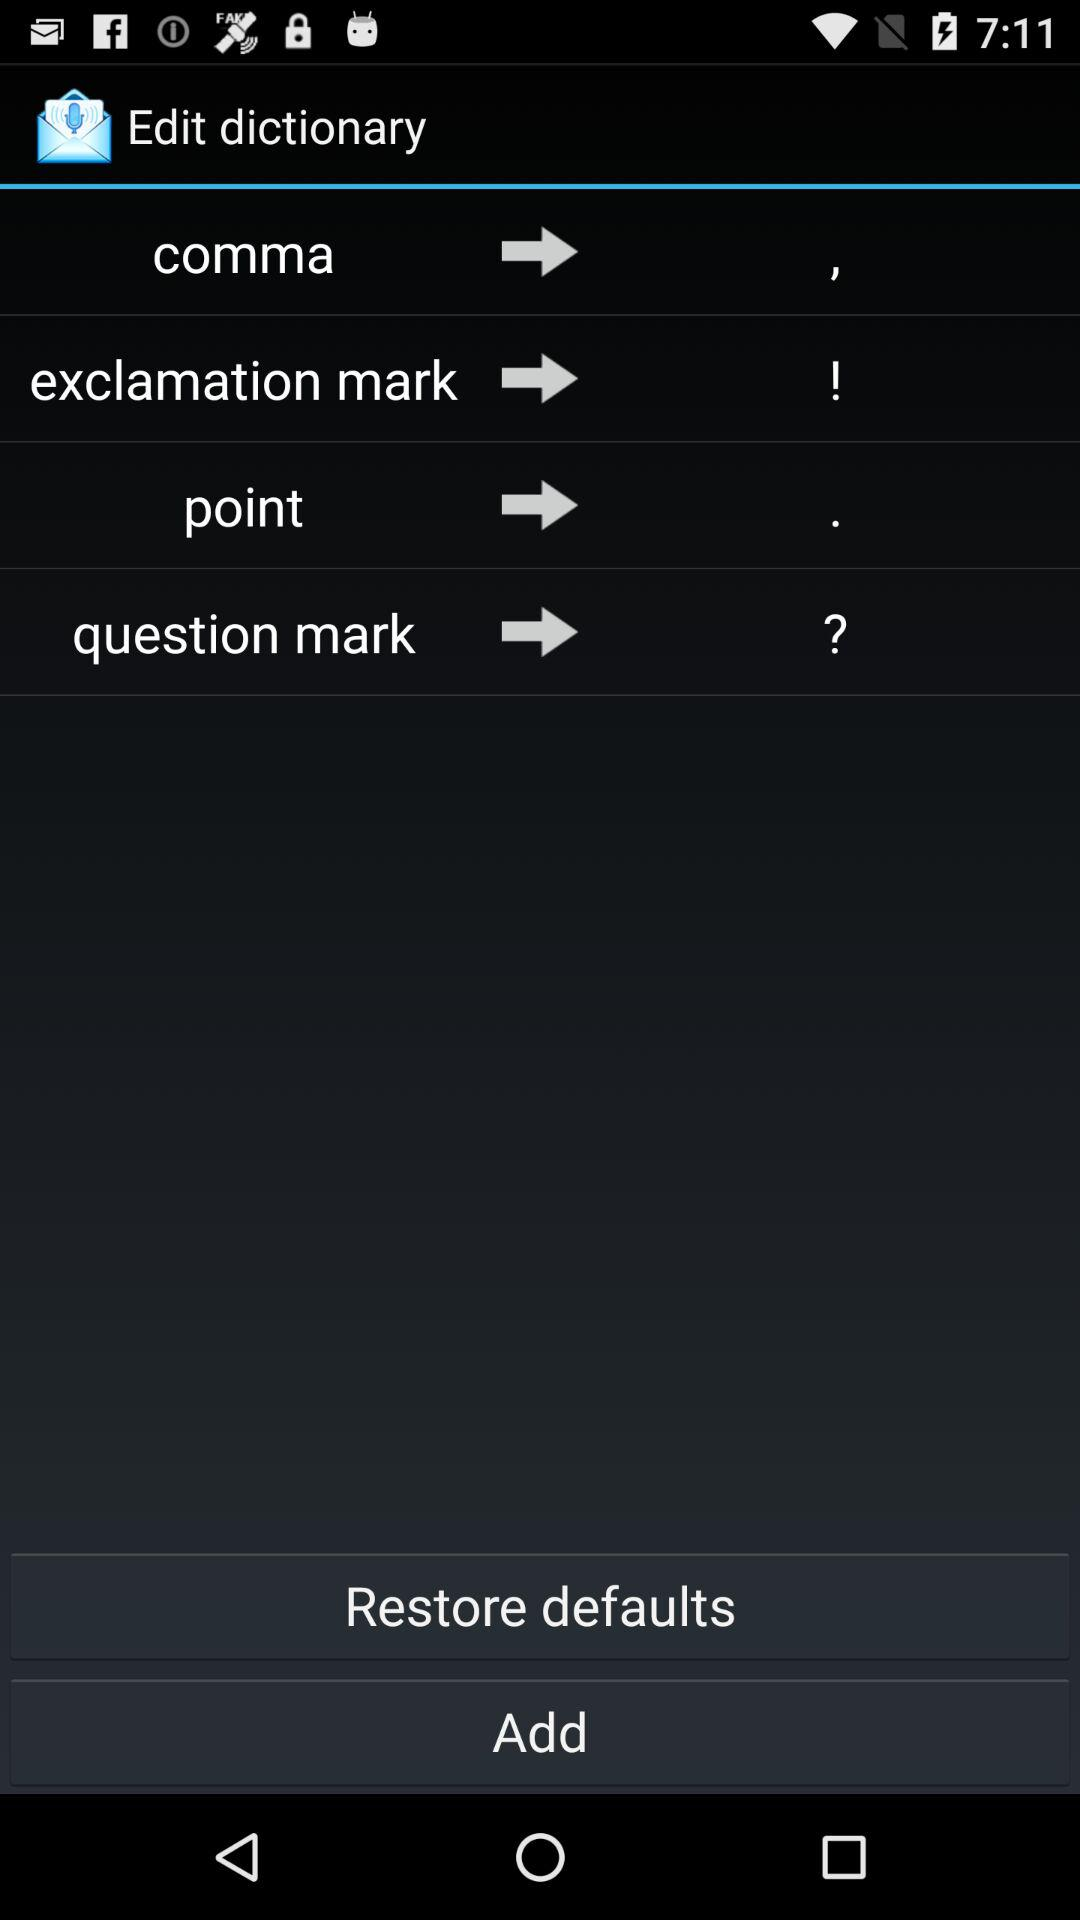How many of the punctuation marks are exclamation marks?
Answer the question using a single word or phrase. 1 